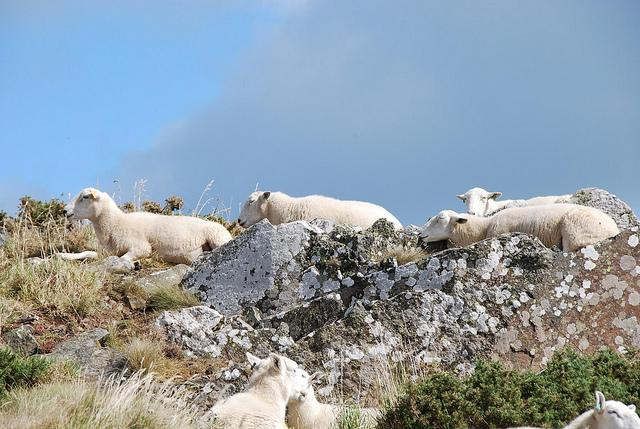What are the animals doing on the hill?

Choices:
A) mating
B) eating
C) fighting
D) sitting sitting 